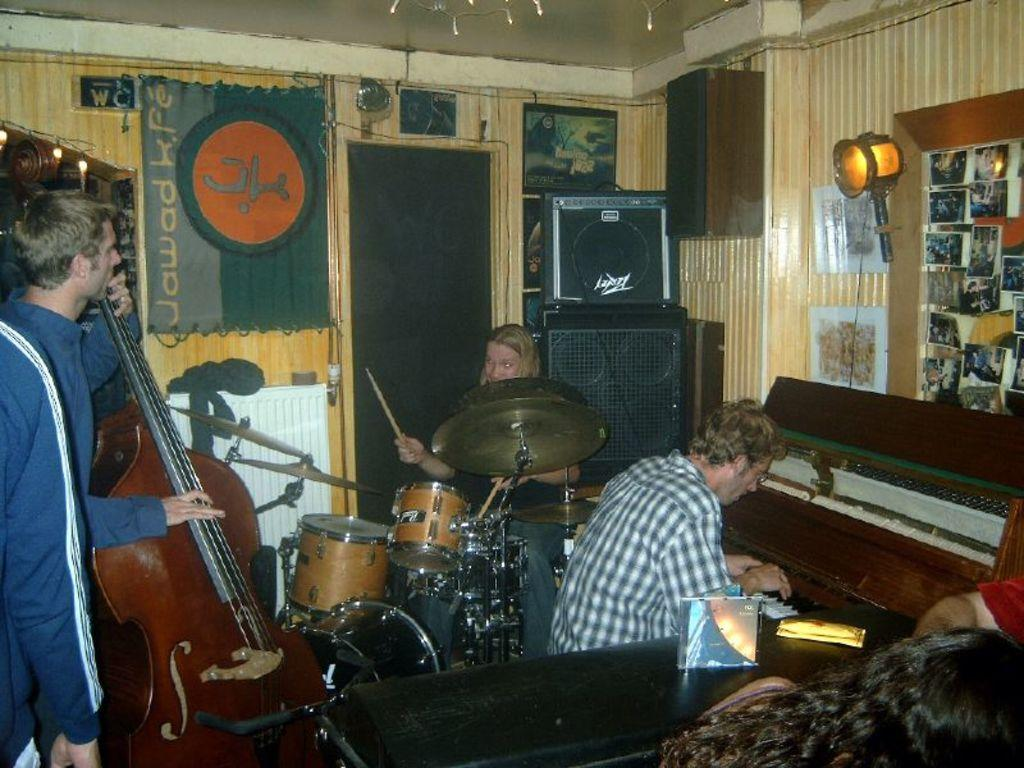What is the man in the image holding? The man is holding a guitar in the image. What other instruments are being played in the image? There is a person playing the drum set and another person playing the piano in the image. How many clovers can be seen in the image? There are no clovers present in the image. What is the income of the person playing the piano in the image? The income of the person playing the piano cannot be determined from the image. 